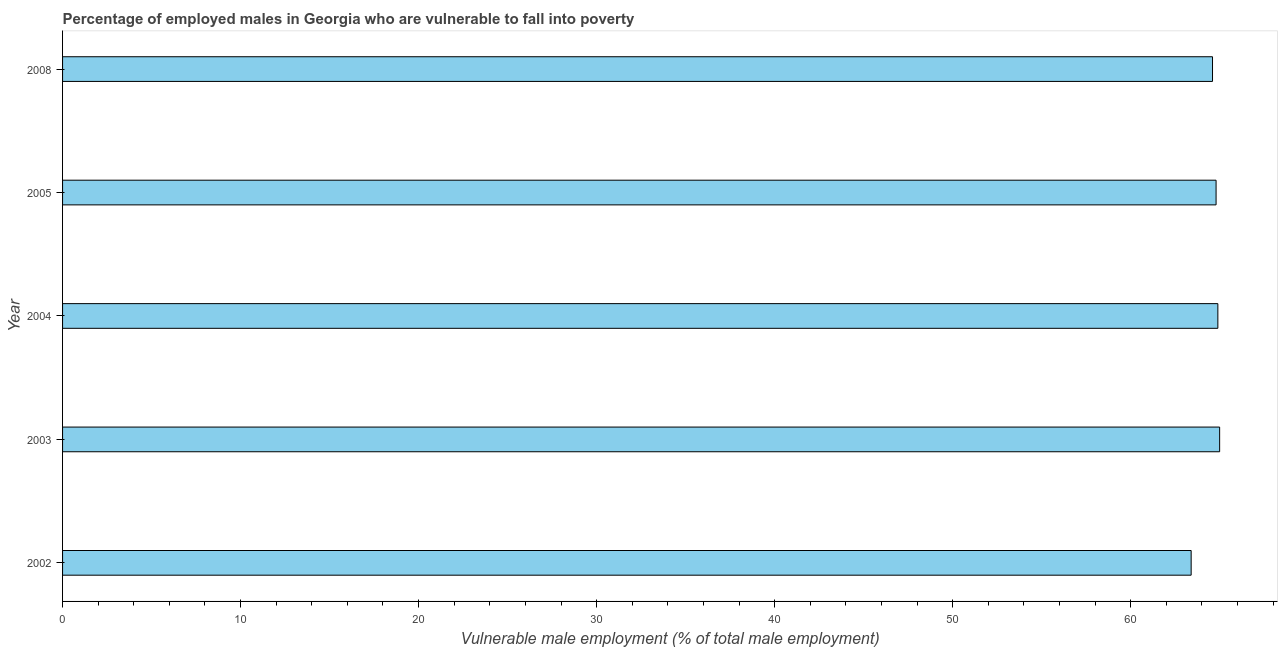Does the graph contain grids?
Your response must be concise. No. What is the title of the graph?
Your response must be concise. Percentage of employed males in Georgia who are vulnerable to fall into poverty. What is the label or title of the X-axis?
Give a very brief answer. Vulnerable male employment (% of total male employment). What is the percentage of employed males who are vulnerable to fall into poverty in 2005?
Your response must be concise. 64.8. Across all years, what is the maximum percentage of employed males who are vulnerable to fall into poverty?
Provide a succinct answer. 65. Across all years, what is the minimum percentage of employed males who are vulnerable to fall into poverty?
Give a very brief answer. 63.4. In which year was the percentage of employed males who are vulnerable to fall into poverty maximum?
Make the answer very short. 2003. In which year was the percentage of employed males who are vulnerable to fall into poverty minimum?
Provide a succinct answer. 2002. What is the sum of the percentage of employed males who are vulnerable to fall into poverty?
Ensure brevity in your answer.  322.7. What is the average percentage of employed males who are vulnerable to fall into poverty per year?
Keep it short and to the point. 64.54. What is the median percentage of employed males who are vulnerable to fall into poverty?
Your response must be concise. 64.8. Do a majority of the years between 2003 and 2004 (inclusive) have percentage of employed males who are vulnerable to fall into poverty greater than 8 %?
Provide a short and direct response. Yes. What is the ratio of the percentage of employed males who are vulnerable to fall into poverty in 2005 to that in 2008?
Your response must be concise. 1. What is the difference between the highest and the second highest percentage of employed males who are vulnerable to fall into poverty?
Your answer should be compact. 0.1. Is the sum of the percentage of employed males who are vulnerable to fall into poverty in 2002 and 2004 greater than the maximum percentage of employed males who are vulnerable to fall into poverty across all years?
Ensure brevity in your answer.  Yes. What is the difference between the highest and the lowest percentage of employed males who are vulnerable to fall into poverty?
Offer a very short reply. 1.6. In how many years, is the percentage of employed males who are vulnerable to fall into poverty greater than the average percentage of employed males who are vulnerable to fall into poverty taken over all years?
Ensure brevity in your answer.  4. How many years are there in the graph?
Make the answer very short. 5. What is the difference between two consecutive major ticks on the X-axis?
Provide a succinct answer. 10. What is the Vulnerable male employment (% of total male employment) in 2002?
Make the answer very short. 63.4. What is the Vulnerable male employment (% of total male employment) in 2004?
Your answer should be very brief. 64.9. What is the Vulnerable male employment (% of total male employment) in 2005?
Keep it short and to the point. 64.8. What is the Vulnerable male employment (% of total male employment) in 2008?
Your answer should be very brief. 64.6. What is the difference between the Vulnerable male employment (% of total male employment) in 2002 and 2005?
Give a very brief answer. -1.4. What is the difference between the Vulnerable male employment (% of total male employment) in 2003 and 2004?
Provide a short and direct response. 0.1. What is the difference between the Vulnerable male employment (% of total male employment) in 2003 and 2005?
Keep it short and to the point. 0.2. What is the difference between the Vulnerable male employment (% of total male employment) in 2004 and 2008?
Your response must be concise. 0.3. What is the difference between the Vulnerable male employment (% of total male employment) in 2005 and 2008?
Keep it short and to the point. 0.2. What is the ratio of the Vulnerable male employment (% of total male employment) in 2002 to that in 2004?
Provide a short and direct response. 0.98. What is the ratio of the Vulnerable male employment (% of total male employment) in 2003 to that in 2005?
Your response must be concise. 1. What is the ratio of the Vulnerable male employment (% of total male employment) in 2003 to that in 2008?
Offer a terse response. 1.01. What is the ratio of the Vulnerable male employment (% of total male employment) in 2004 to that in 2008?
Offer a very short reply. 1. 